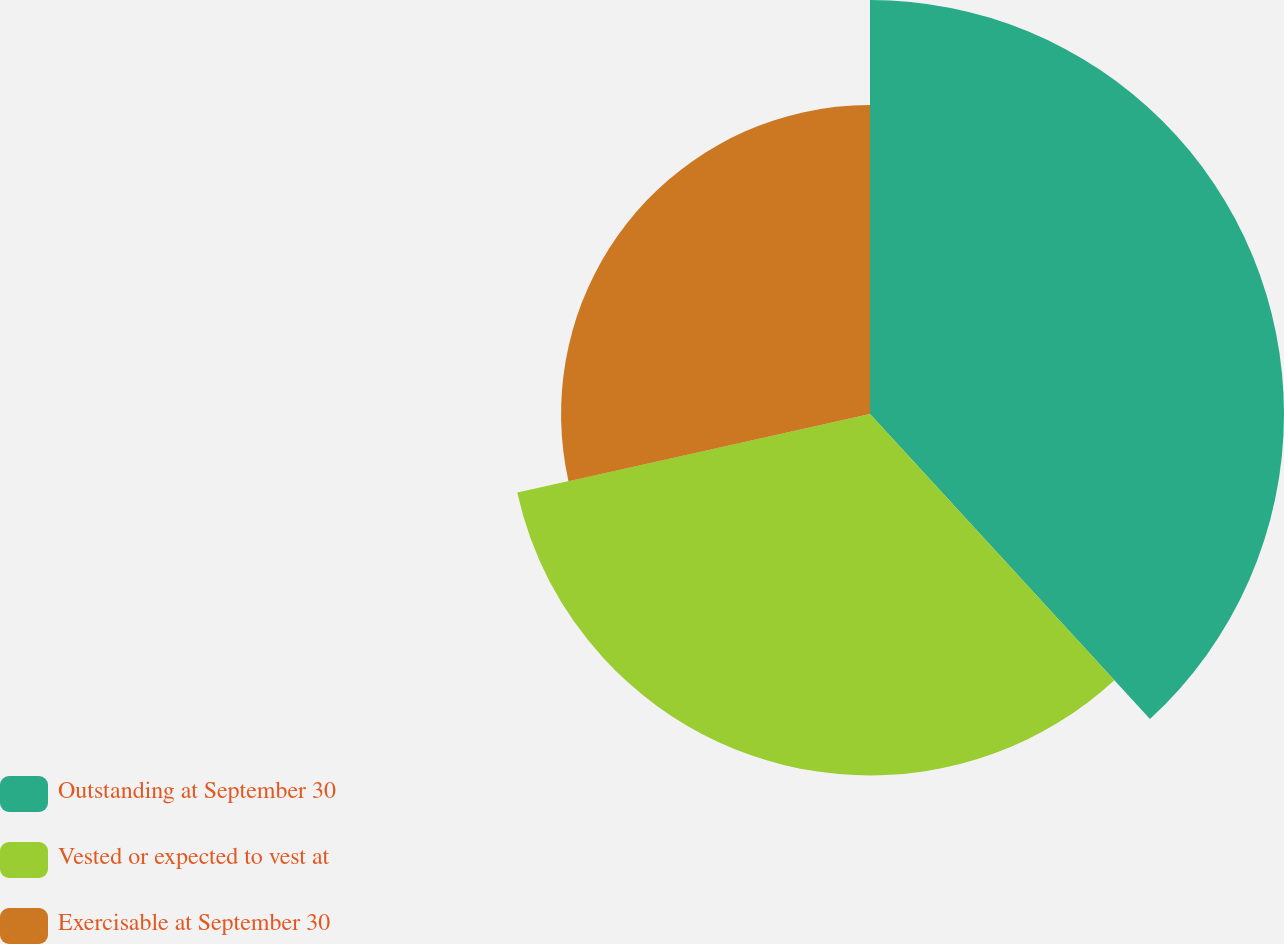<chart> <loc_0><loc_0><loc_500><loc_500><pie_chart><fcel>Outstanding at September 30<fcel>Vested or expected to vest at<fcel>Exercisable at September 30<nl><fcel>38.18%<fcel>33.33%<fcel>28.49%<nl></chart> 